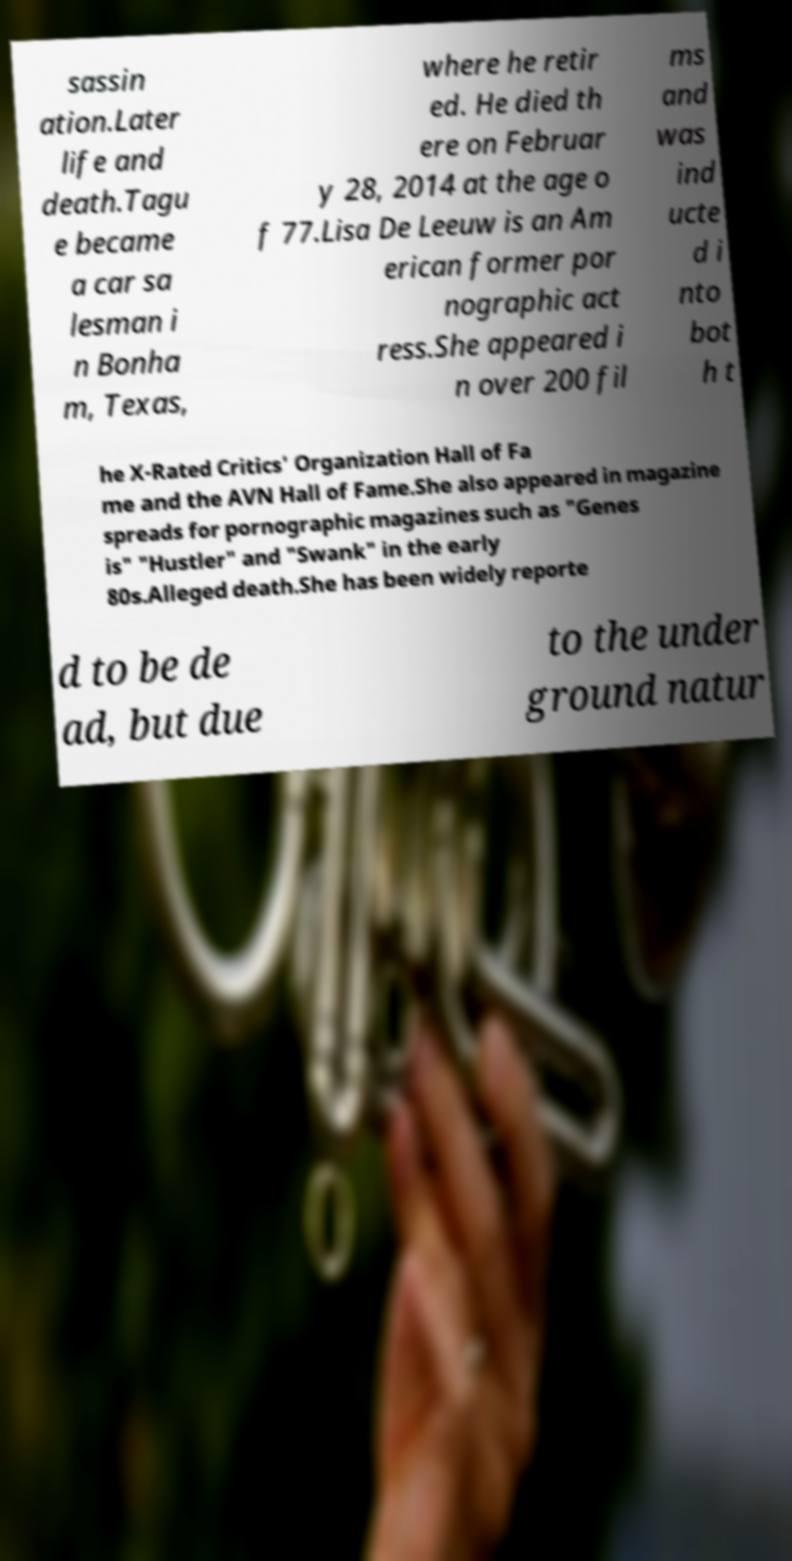Please identify and transcribe the text found in this image. sassin ation.Later life and death.Tagu e became a car sa lesman i n Bonha m, Texas, where he retir ed. He died th ere on Februar y 28, 2014 at the age o f 77.Lisa De Leeuw is an Am erican former por nographic act ress.She appeared i n over 200 fil ms and was ind ucte d i nto bot h t he X-Rated Critics' Organization Hall of Fa me and the AVN Hall of Fame.She also appeared in magazine spreads for pornographic magazines such as "Genes is" "Hustler" and "Swank" in the early 80s.Alleged death.She has been widely reporte d to be de ad, but due to the under ground natur 